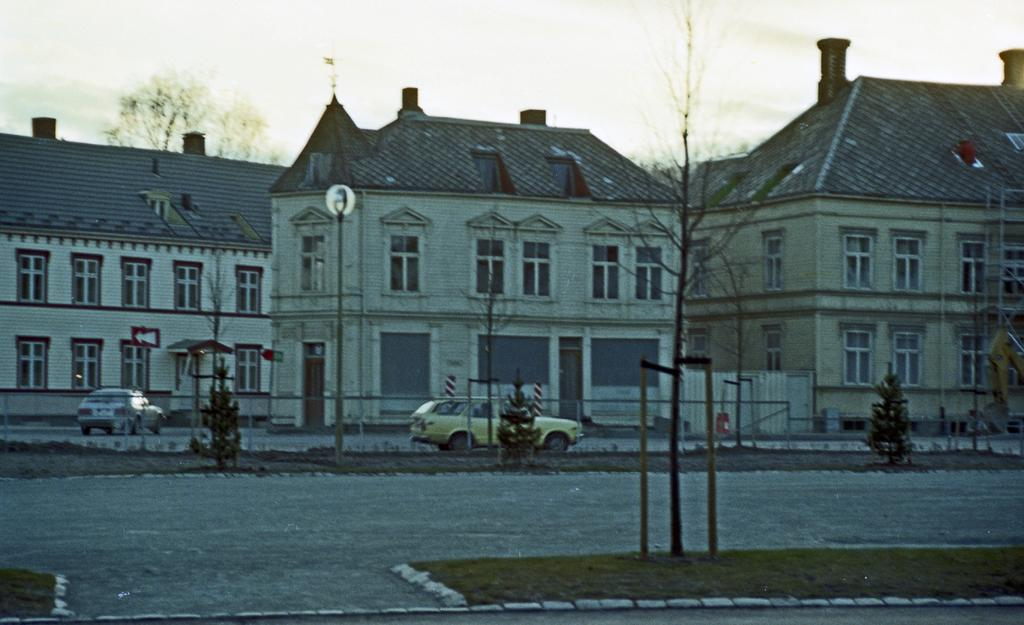What can be seen on the road in the image? There are vehicles on the road in the image. What is visible in the background of the image? There are buildings, trees, poles, and the sky visible in the background of the image. What is the secretary's daughter learning in the image? There is no secretary or daughter present in the image, so it is not possible to answer that question. 